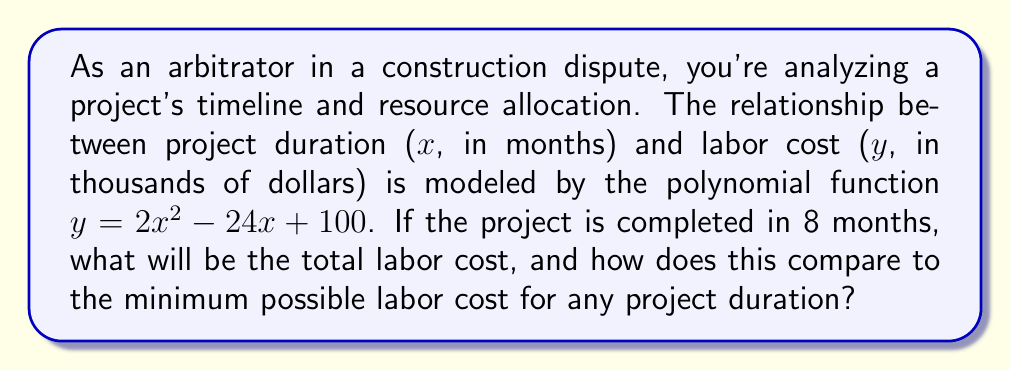What is the answer to this math problem? 1. To find the labor cost for an 8-month project, substitute x = 8 into the given function:
   $y = 2(8)^2 - 24(8) + 100$
   $y = 2(64) - 192 + 100$
   $y = 128 - 192 + 100 = 36$

   The labor cost for an 8-month project is $36,000.

2. To find the minimum possible labor cost, we need to find the vertex of the parabola:
   For a quadratic function $f(x) = ax^2 + bx + c$, the x-coordinate of the vertex is given by $x = -\frac{b}{2a}$

   Here, $a = 2$, $b = -24$, so:
   $x = -\frac{-24}{2(2)} = \frac{24}{4} = 6$

3. The minimum labor cost occurs when x = 6. Substitute this into the original function:
   $y = 2(6)^2 - 24(6) + 100$
   $y = 2(36) - 144 + 100$
   $y = 72 - 144 + 100 = 28$

   The minimum possible labor cost is $28,000.

4. Compare the two values:
   Labor cost for 8-month project: $36,000
   Minimum possible labor cost: $28,000
   Difference: $36,000 - $28,000 = $8,000
Answer: $36,000; $8,000 higher than minimum 